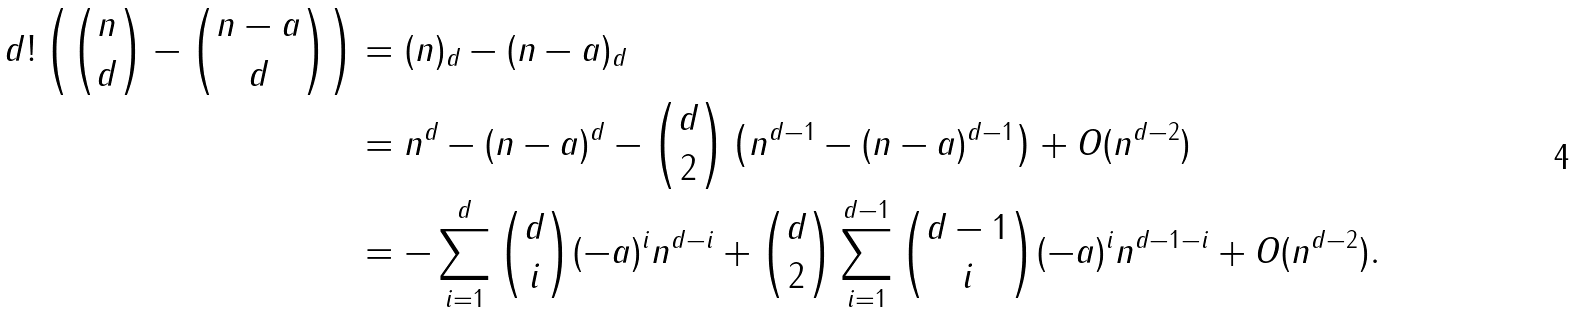<formula> <loc_0><loc_0><loc_500><loc_500>d ! \left ( { n \choose d } - { n - a \choose d } \right ) & = ( n ) _ { d } - ( n - a ) _ { d } \\ & = n ^ { d } - ( n - a ) ^ { d } - { d \choose 2 } \left ( n ^ { d - 1 } - ( n - a ) ^ { d - 1 } \right ) + O ( n ^ { d - 2 } ) \\ & = - \sum _ { i = 1 } ^ { d } { d \choose i } ( - a ) ^ { i } n ^ { d - i } + { d \choose 2 } \sum _ { i = 1 } ^ { d - 1 } { d - 1 \choose i } ( - a ) ^ { i } n ^ { d - 1 - i } + O ( n ^ { d - 2 } ) .</formula> 